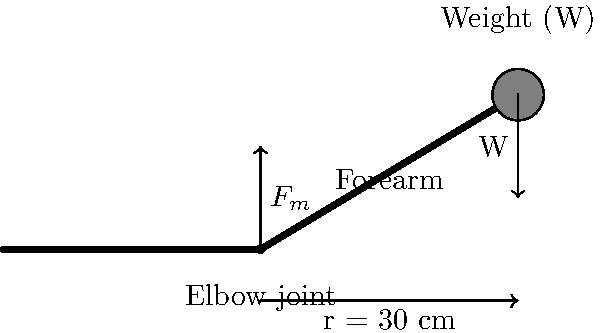As an educator with experience in biomechanics, consider a bicep curl exercise where a person is holding a 5 kg weight. The distance from the elbow joint to the center of the weight is 30 cm. Calculate the torque generated at the elbow joint when the forearm is horizontal. Assume g = 9.8 m/s². To calculate the torque at the elbow joint, we'll follow these steps:

1. Identify the force causing the torque:
   The weight (W) of the dumbbell causes the torque.

2. Calculate the weight force:
   $W = mg = 5 \text{ kg} \times 9.8 \text{ m/s}^2 = 49 \text{ N}$

3. Identify the moment arm:
   The perpendicular distance from the axis of rotation (elbow joint) to the line of action of the force is the forearm length, 30 cm or 0.3 m.

4. Apply the torque formula:
   $\tau = r \times F$
   Where:
   $\tau$ is the torque
   $r$ is the moment arm
   $F$ is the force (weight in this case)

5. Calculate the torque:
   $\tau = 0.3 \text{ m} \times 49 \text{ N} = 14.7 \text{ N·m}$

The torque is acting to rotate the forearm downward around the elbow joint.
Answer: 14.7 N·m 